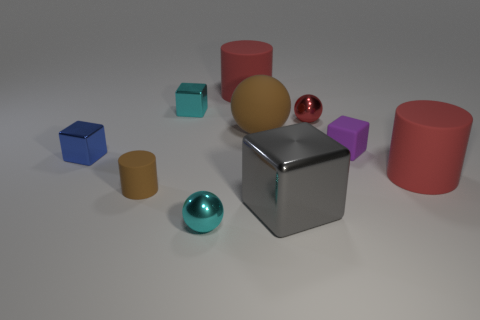There is a large object that is the same color as the small cylinder; what is it made of?
Your answer should be very brief. Rubber. Do the big cylinder behind the cyan metal block and the cylinder to the left of the cyan ball have the same material?
Your answer should be compact. Yes. Are there any tiny purple cylinders?
Your response must be concise. No. Are there more shiny cubes in front of the tiny brown rubber object than large brown matte spheres that are in front of the big gray shiny object?
Give a very brief answer. Yes. There is a gray thing that is the same shape as the tiny purple object; what is its material?
Offer a terse response. Metal. Does the big rubber thing that is on the left side of the brown ball have the same color as the cylinder that is to the right of the tiny red metallic object?
Provide a succinct answer. Yes. The blue thing has what shape?
Offer a terse response. Cube. Are there more matte things on the right side of the small brown thing than tiny cylinders?
Your answer should be compact. Yes. There is a tiny rubber object that is in front of the small blue shiny object; what is its shape?
Provide a short and direct response. Cylinder. What number of other objects are there of the same shape as the small blue object?
Give a very brief answer. 3. 